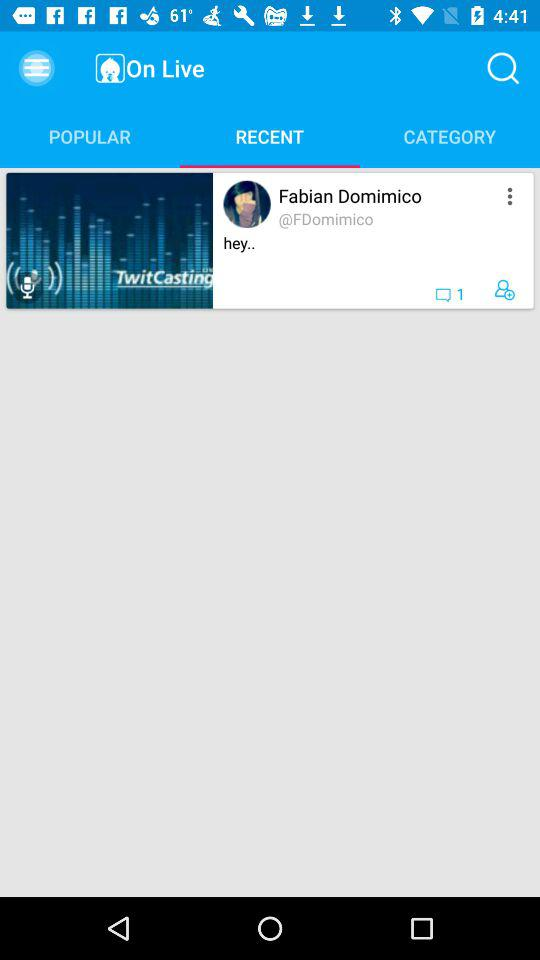What is the name of the application? The name of the application is "TwitCasting VIEWER". 